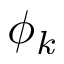<formula> <loc_0><loc_0><loc_500><loc_500>\phi _ { k }</formula> 